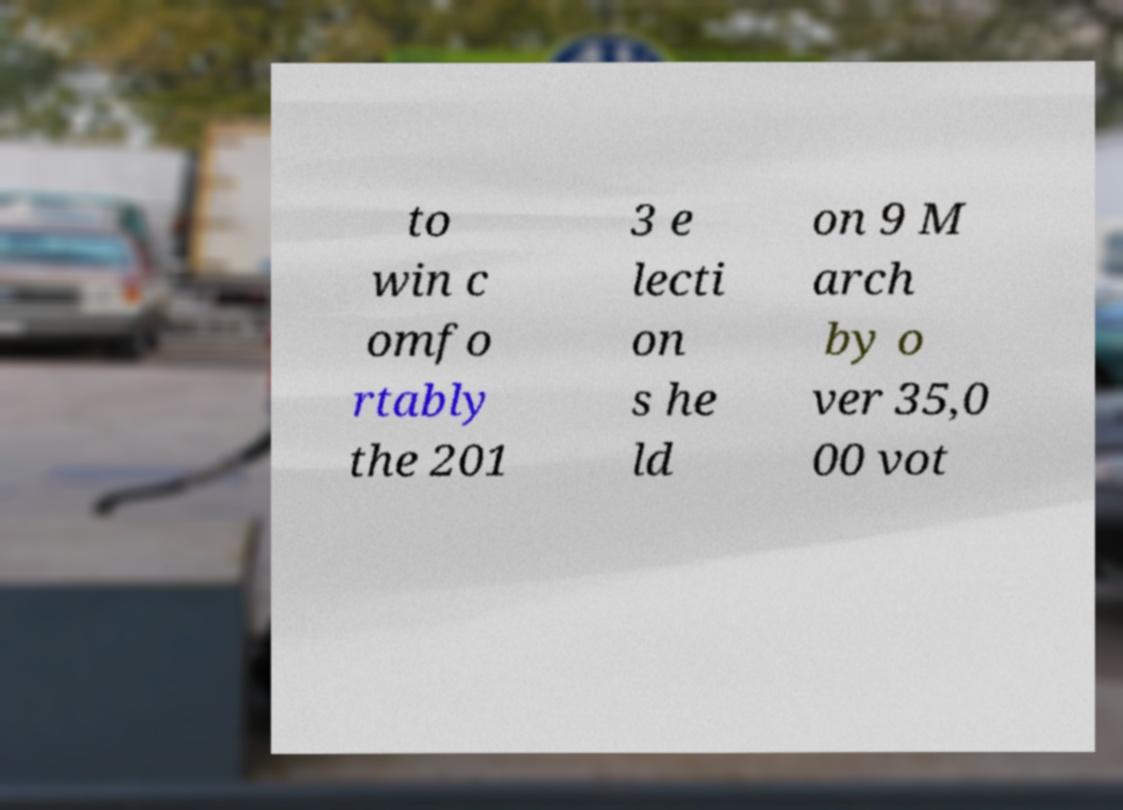For documentation purposes, I need the text within this image transcribed. Could you provide that? to win c omfo rtably the 201 3 e lecti on s he ld on 9 M arch by o ver 35,0 00 vot 